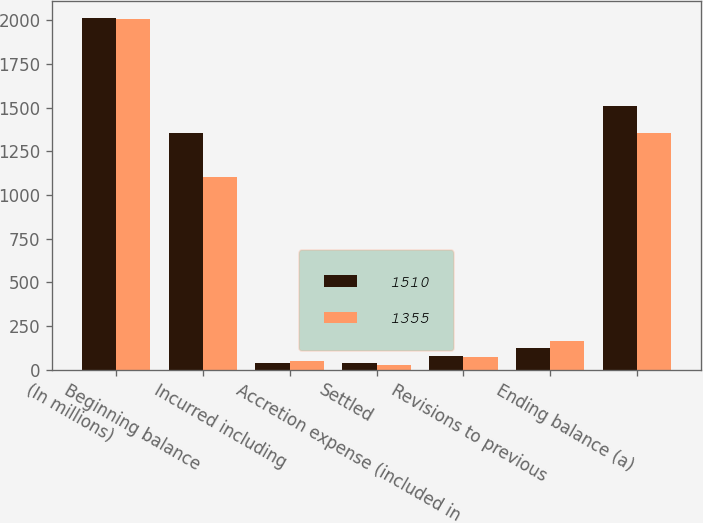Convert chart to OTSL. <chart><loc_0><loc_0><loc_500><loc_500><stacked_bar_chart><ecel><fcel>(In millions)<fcel>Beginning balance<fcel>Incurred including<fcel>Settled<fcel>Accretion expense (included in<fcel>Revisions to previous<fcel>Ending balance (a)<nl><fcel>1510<fcel>2011<fcel>1355<fcel>37<fcel>39<fcel>81<fcel>126<fcel>1510<nl><fcel>1355<fcel>2010<fcel>1102<fcel>49<fcel>28<fcel>70<fcel>162<fcel>1355<nl></chart> 